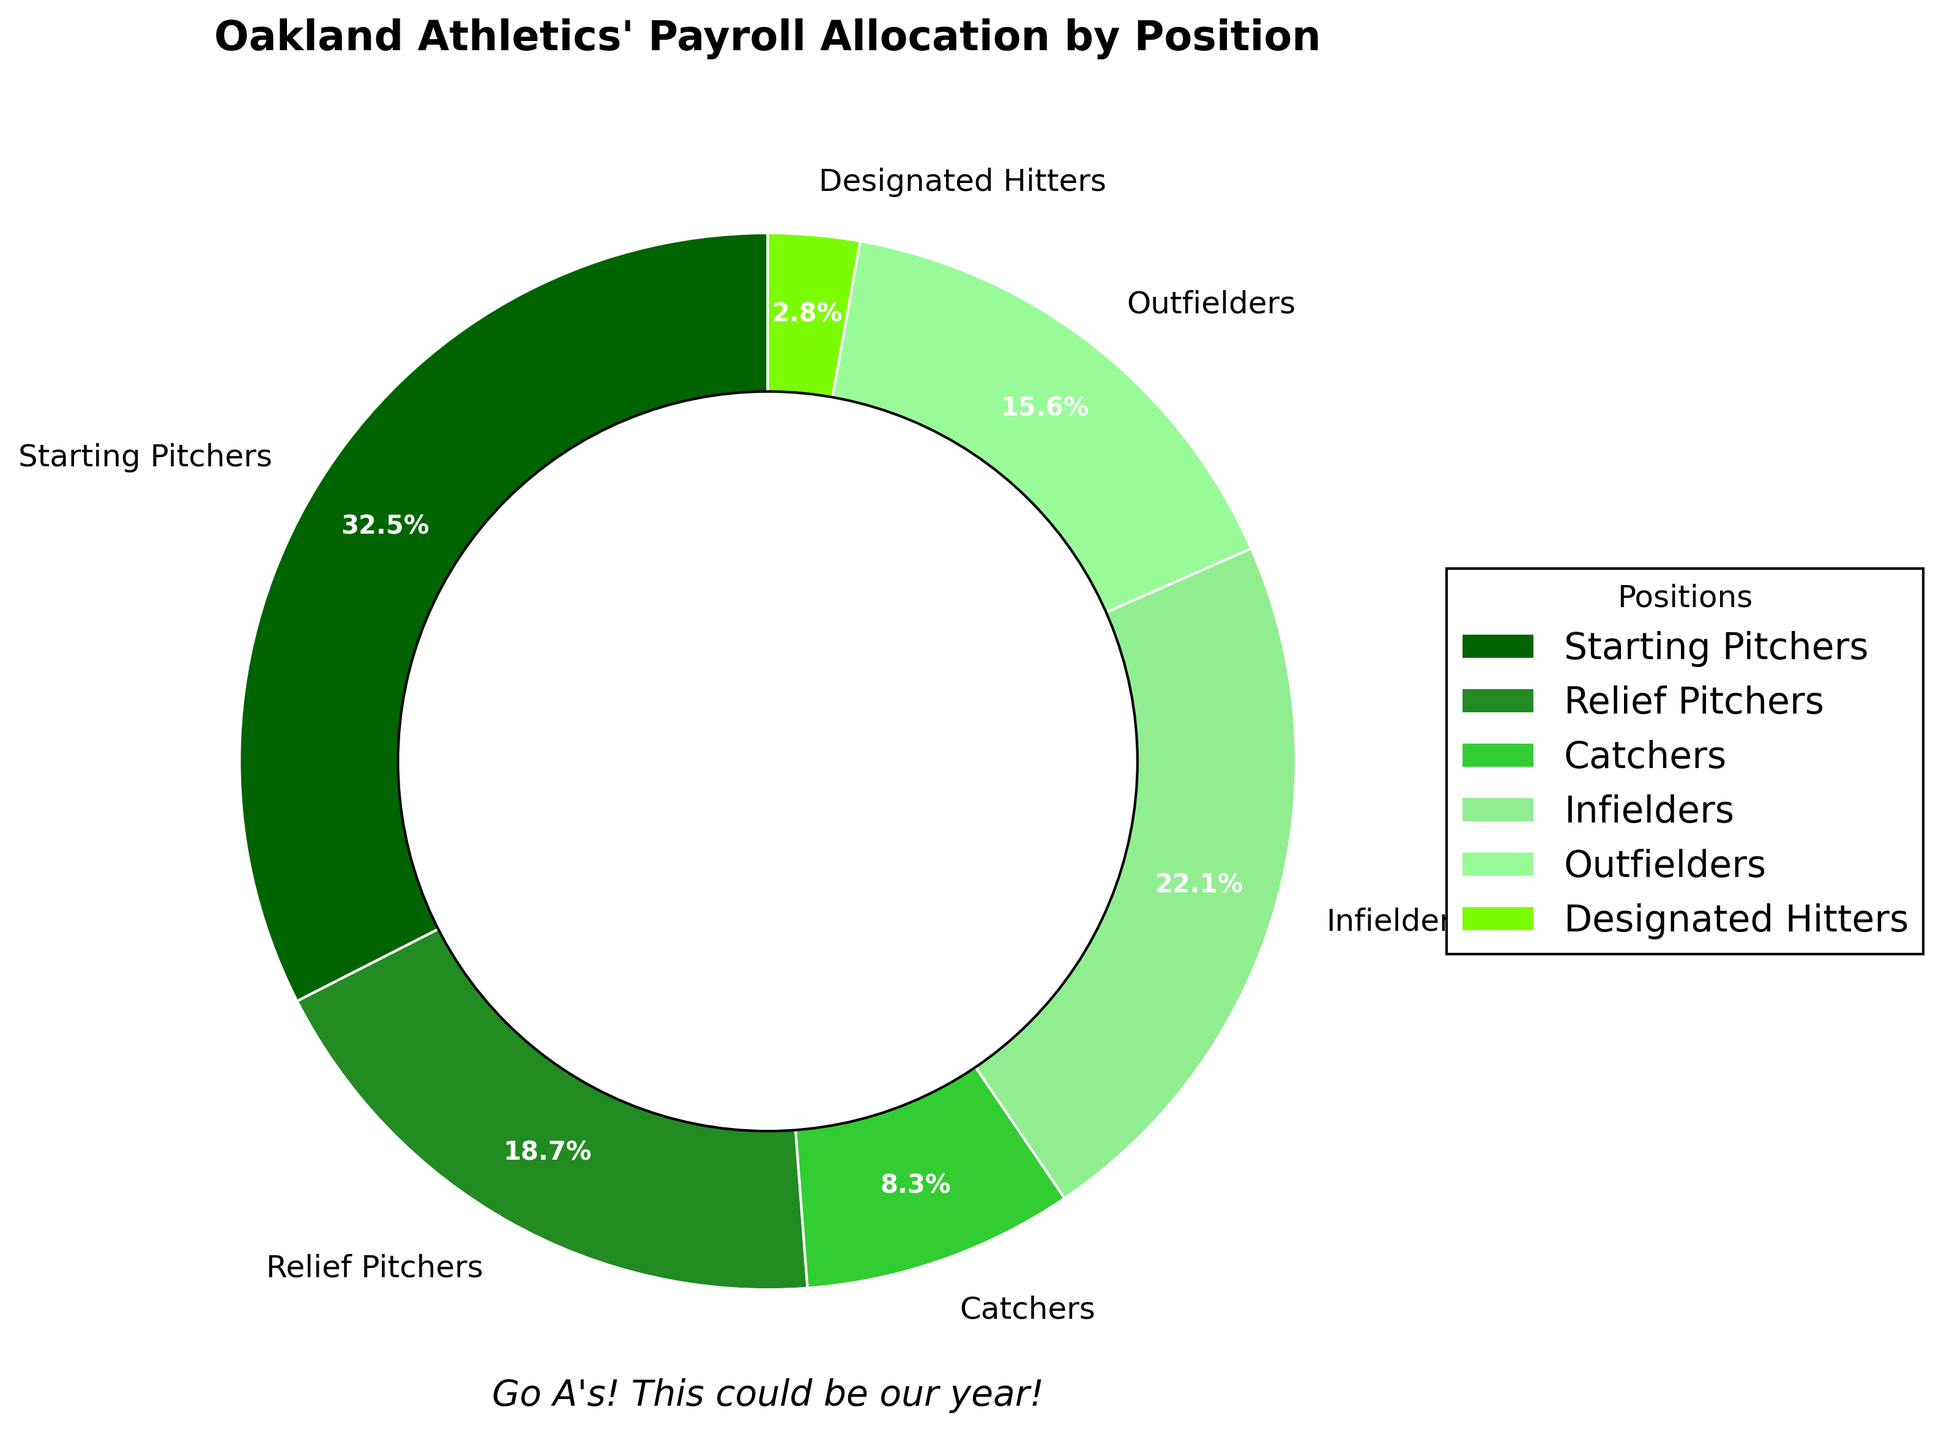What's the position with the highest payroll allocation? The pie chart shows "Starting Pitchers" with the largest segment. This means they represent the highest payroll allocation.
Answer: Starting Pitchers Which positions have a payroll allocation lower than 10%? By examining the pie chart, we see the segments for "Catchers" (8.3%) and "Designated Hitters" (2.8%) are both below 10%.
Answer: Catchers, Designated Hitters What is the combined payroll percentage for infielders and outfielders? Sum the percentages for "Infielders" (22.1%) and "Outfielders" (15.6%): 22.1 + 15.6 = 37.7.
Answer: 37.7% Which position has a payroll allocation of 18.7%? Referring to the pie chart, "Relief Pitchers" are explicitly marked with a payroll allocation of 18.7%.
Answer: Relief Pitchers What is the difference in payroll allocation between Starting Pitchers and Designated Hitters? Subtract the percentage for "Designated Hitters" from "Starting Pitchers": 32.5 - 2.8 = 29.7.
Answer: 29.7% How much more is allocated to infielders compared to outfielders? The pie chart shows "Infielders" have 22.1% and "Outfielders" have 15.6%. The difference is 22.1 - 15.6 = 6.5.
Answer: 6.5% What is the total payroll allocation for pitchers (both starting and relief)? Add the percentages for "Starting Pitchers" (32.5%) and "Relief Pitchers" (18.7%): 32.5 + 18.7 = 51.2.
Answer: 51.2% How does the payroll allocation for catchers compare to that of designated hitters? By comparing the two percentages, we see "Catchers" have 8.3% and "Designated Hitters" have 2.8%. 8.3 is greater than 2.8.
Answer: Catchers have a higher percentage What percentage of the payroll is allocated to positions other than pitchers? First, calculate the total percentage for pitchers: 32.5 + 18.7 = 51.2%. Then subtract this from 100%: 100 - 51.2 = 48.8.
Answer: 48.8% 